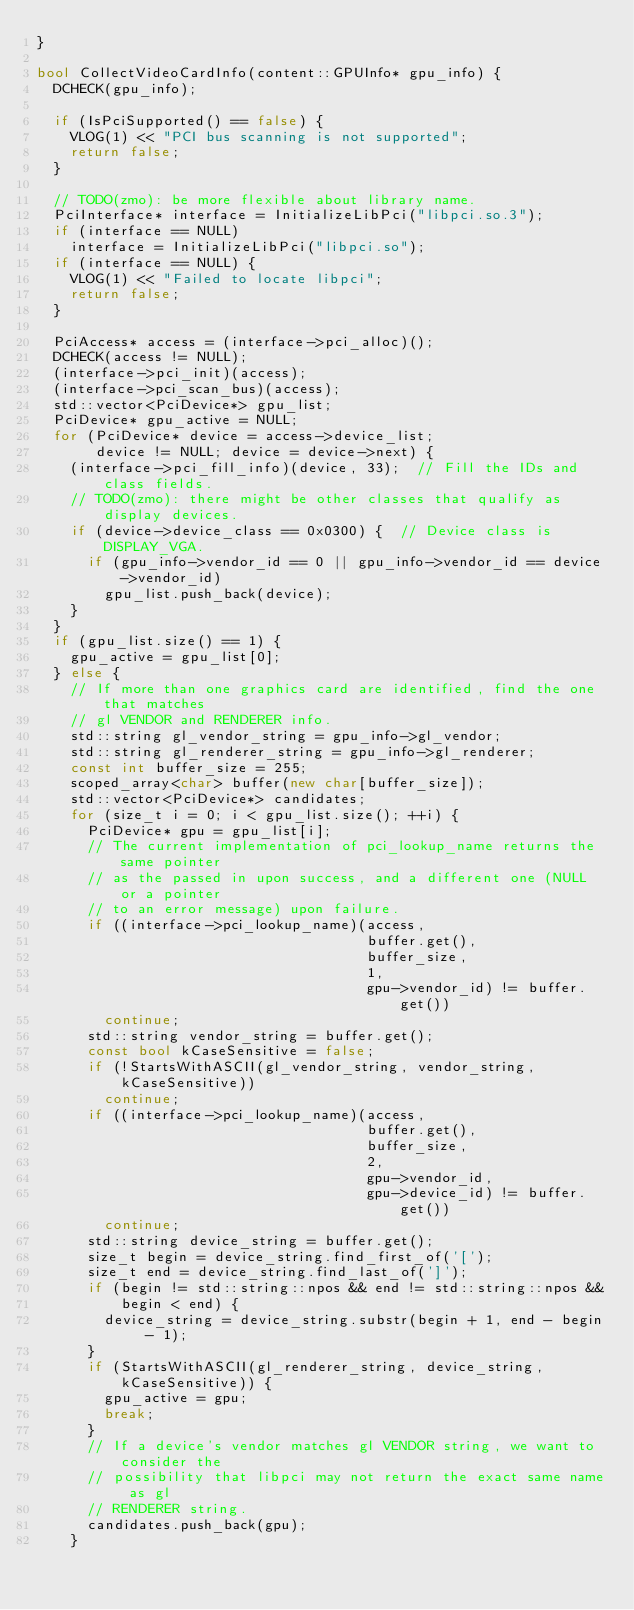<code> <loc_0><loc_0><loc_500><loc_500><_C++_>}

bool CollectVideoCardInfo(content::GPUInfo* gpu_info) {
  DCHECK(gpu_info);

  if (IsPciSupported() == false) {
    VLOG(1) << "PCI bus scanning is not supported";
    return false;
  }

  // TODO(zmo): be more flexible about library name.
  PciInterface* interface = InitializeLibPci("libpci.so.3");
  if (interface == NULL)
    interface = InitializeLibPci("libpci.so");
  if (interface == NULL) {
    VLOG(1) << "Failed to locate libpci";
    return false;
  }

  PciAccess* access = (interface->pci_alloc)();
  DCHECK(access != NULL);
  (interface->pci_init)(access);
  (interface->pci_scan_bus)(access);
  std::vector<PciDevice*> gpu_list;
  PciDevice* gpu_active = NULL;
  for (PciDevice* device = access->device_list;
       device != NULL; device = device->next) {
    (interface->pci_fill_info)(device, 33);  // Fill the IDs and class fields.
    // TODO(zmo): there might be other classes that qualify as display devices.
    if (device->device_class == 0x0300) {  // Device class is DISPLAY_VGA.
      if (gpu_info->vendor_id == 0 || gpu_info->vendor_id == device->vendor_id)
        gpu_list.push_back(device);
    }
  }
  if (gpu_list.size() == 1) {
    gpu_active = gpu_list[0];
  } else {
    // If more than one graphics card are identified, find the one that matches
    // gl VENDOR and RENDERER info.
    std::string gl_vendor_string = gpu_info->gl_vendor;
    std::string gl_renderer_string = gpu_info->gl_renderer;
    const int buffer_size = 255;
    scoped_array<char> buffer(new char[buffer_size]);
    std::vector<PciDevice*> candidates;
    for (size_t i = 0; i < gpu_list.size(); ++i) {
      PciDevice* gpu = gpu_list[i];
      // The current implementation of pci_lookup_name returns the same pointer
      // as the passed in upon success, and a different one (NULL or a pointer
      // to an error message) upon failure.
      if ((interface->pci_lookup_name)(access,
                                       buffer.get(),
                                       buffer_size,
                                       1,
                                       gpu->vendor_id) != buffer.get())
        continue;
      std::string vendor_string = buffer.get();
      const bool kCaseSensitive = false;
      if (!StartsWithASCII(gl_vendor_string, vendor_string, kCaseSensitive))
        continue;
      if ((interface->pci_lookup_name)(access,
                                       buffer.get(),
                                       buffer_size,
                                       2,
                                       gpu->vendor_id,
                                       gpu->device_id) != buffer.get())
        continue;
      std::string device_string = buffer.get();
      size_t begin = device_string.find_first_of('[');
      size_t end = device_string.find_last_of(']');
      if (begin != std::string::npos && end != std::string::npos &&
          begin < end) {
        device_string = device_string.substr(begin + 1, end - begin - 1);
      }
      if (StartsWithASCII(gl_renderer_string, device_string, kCaseSensitive)) {
        gpu_active = gpu;
        break;
      }
      // If a device's vendor matches gl VENDOR string, we want to consider the
      // possibility that libpci may not return the exact same name as gl
      // RENDERER string.
      candidates.push_back(gpu);
    }</code> 